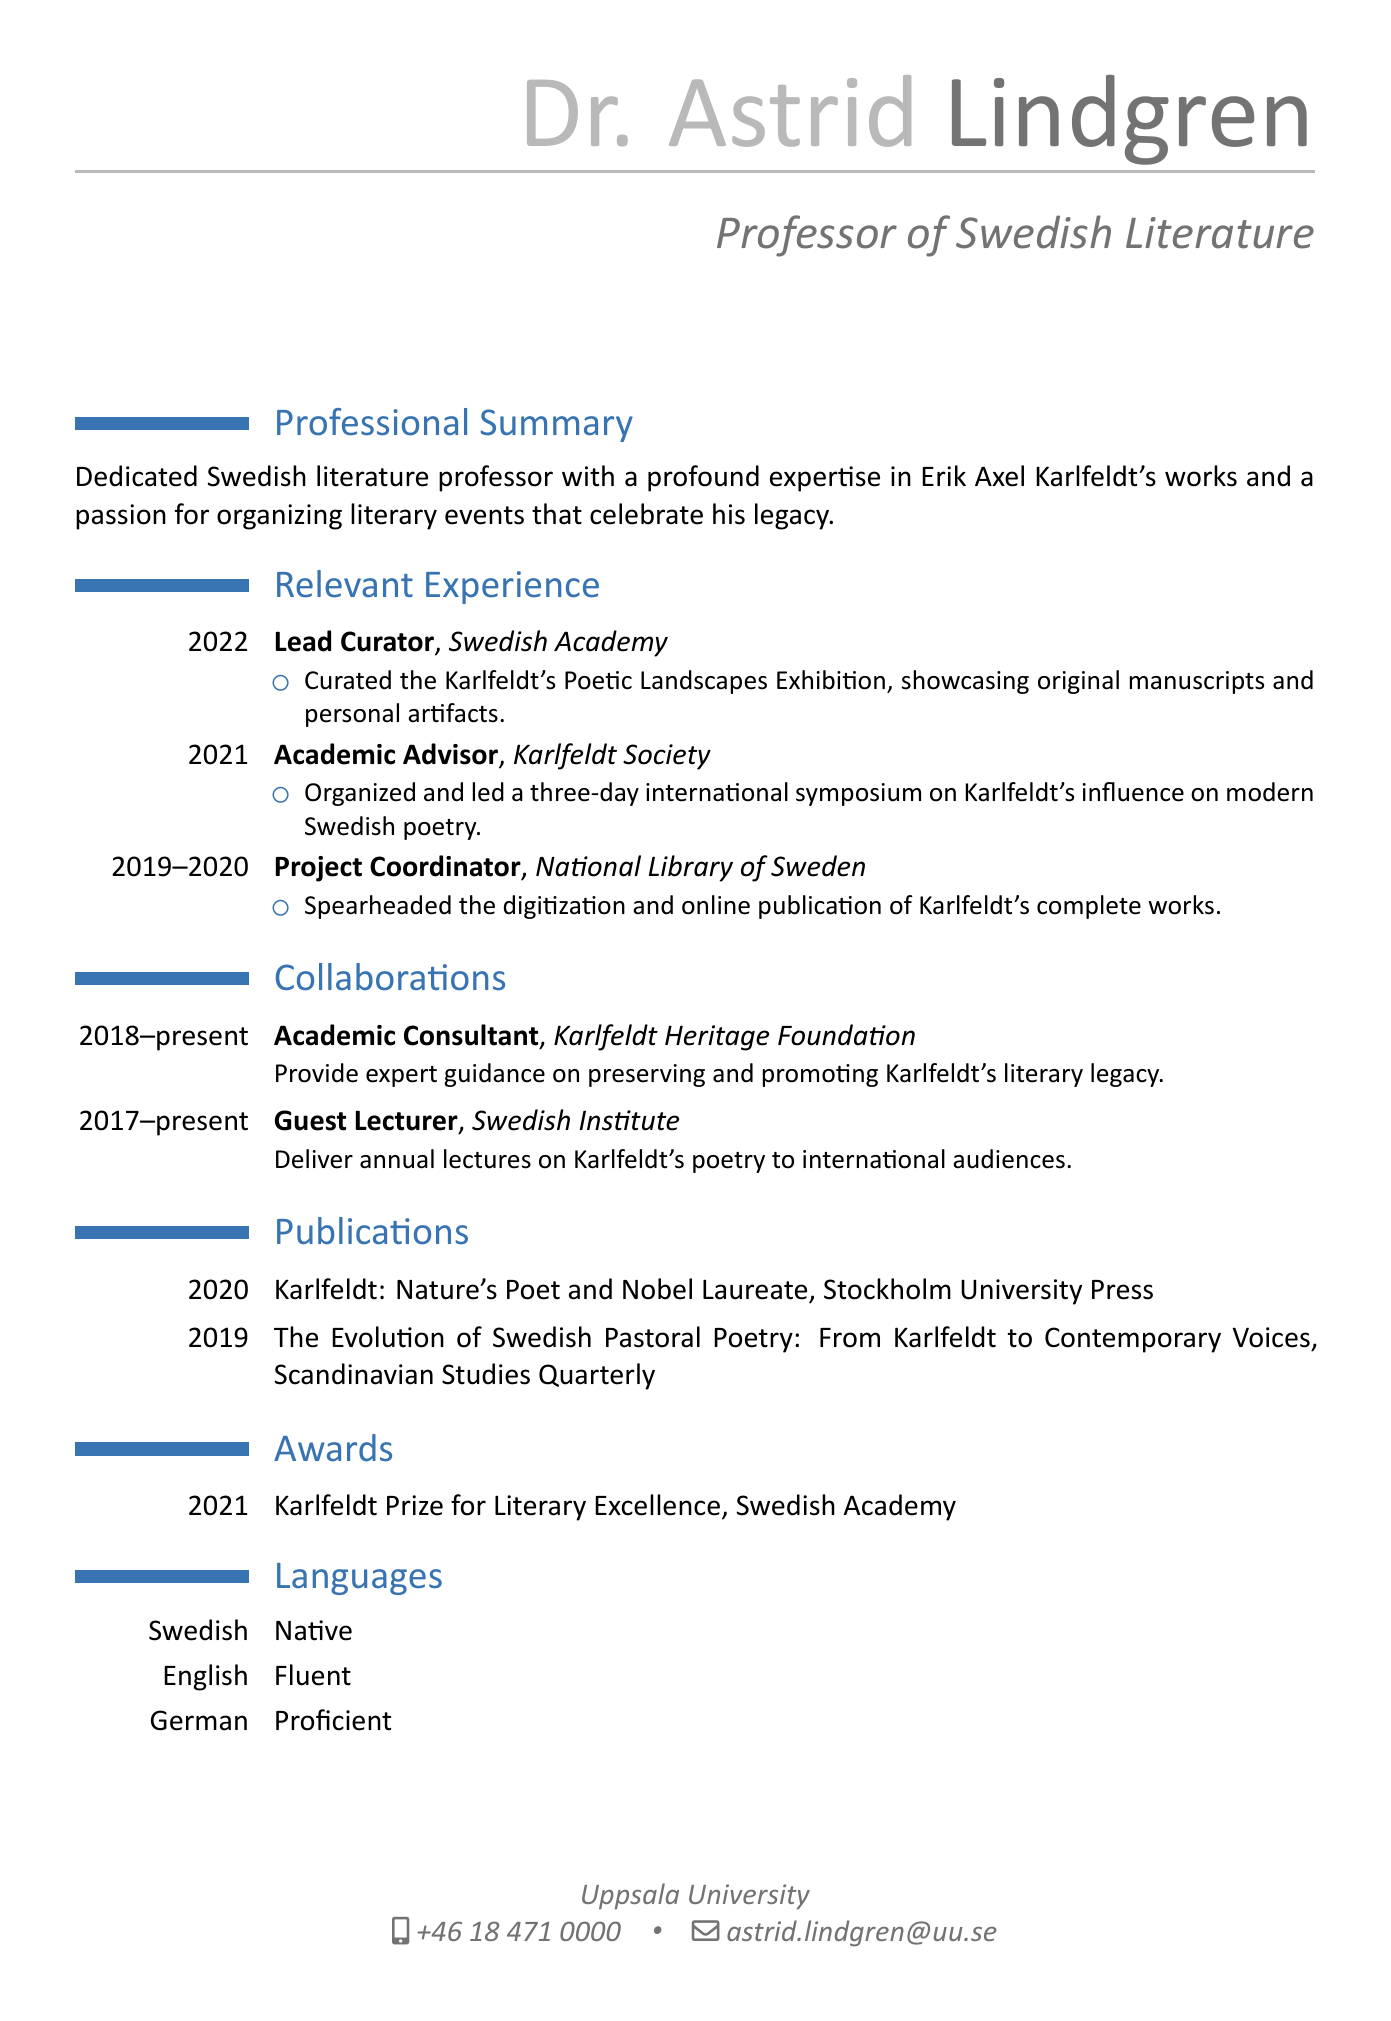What is the name of the professor? The name is provided in the personal information section of the CV.
Answer: Dr. Astrid Lindgren Which institution is the professor affiliated with? This information is listed under personal info, indicating the academic affiliation of Dr. Lindgren.
Answer: Uppsala University What year did Dr. Lindgren curate the Karlfeldt's Poetic Landscapes Exhibition? The year of the event is specified in the relevant experience section of the CV.
Answer: 2022 What role does Dr. Lindgren hold at the Karlfeldt Heritage Foundation? The CV provides the role and years of involvement in the collaborations section.
Answer: Academic Consultant How many languages can Dr. Lindgren speak? The languages section lists the languages along with their levels of proficiency.
Answer: Three What award did Dr. Lindgren receive in 2021? The awards section details Dr. Lindgren's recognitions, including the title of the award and the organization.
Answer: Karlfeldt Prize for Literary Excellence What is one of the topics covered in Dr. Lindgren's publications? The publication titles indicate the subjects addressed by Dr. Lindgren's writings.
Answer: Nature's Poet and Nobel Laureate What event did Dr. Lindgren organize in 2021? The relevant experience section mentions significant events organized by Dr. Lindgren.
Answer: Karlfeldt Symposium What is Dr. Lindgren's role when collaborating with the Swedish Institute? The collaboration section specifies Dr. Lindgren's involvement with this particular institution.
Answer: Guest Lecturer 